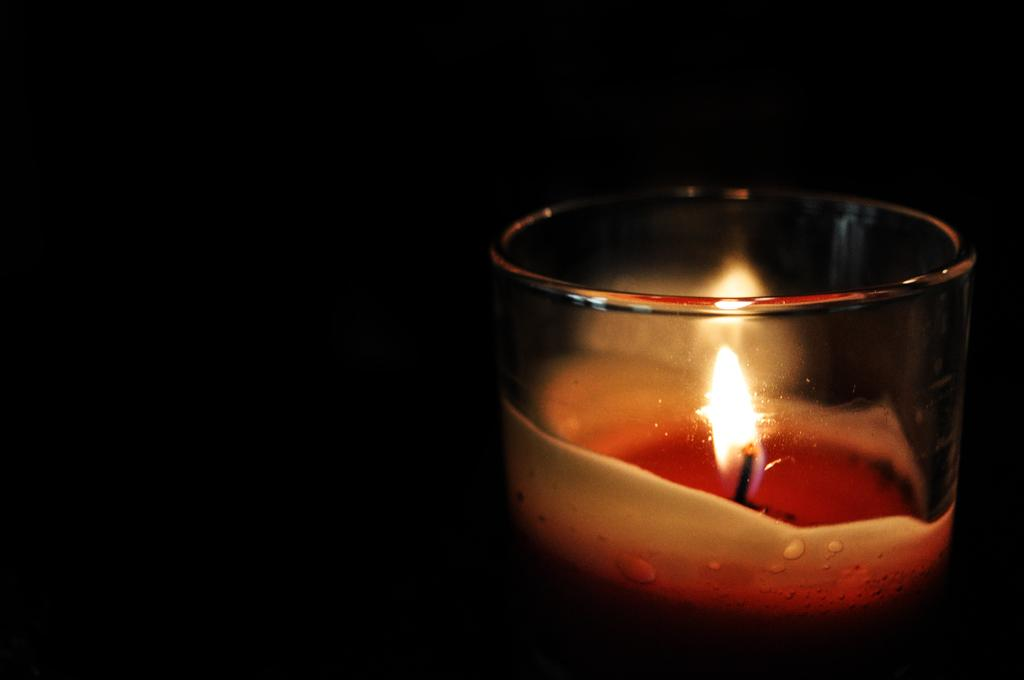What object is visible in the image? There is a glass in the image. What is inside the glass? A candle is present inside the glass. What can be observed about the background of the image? The background of the image is dark. What type of protest is taking place in the image? There is no protest present in the image; it only features a glass with a candle inside and a dark background. What type of liquid is inside the glass? There is no liquid present in the image; it only features a glass with a candle inside. 